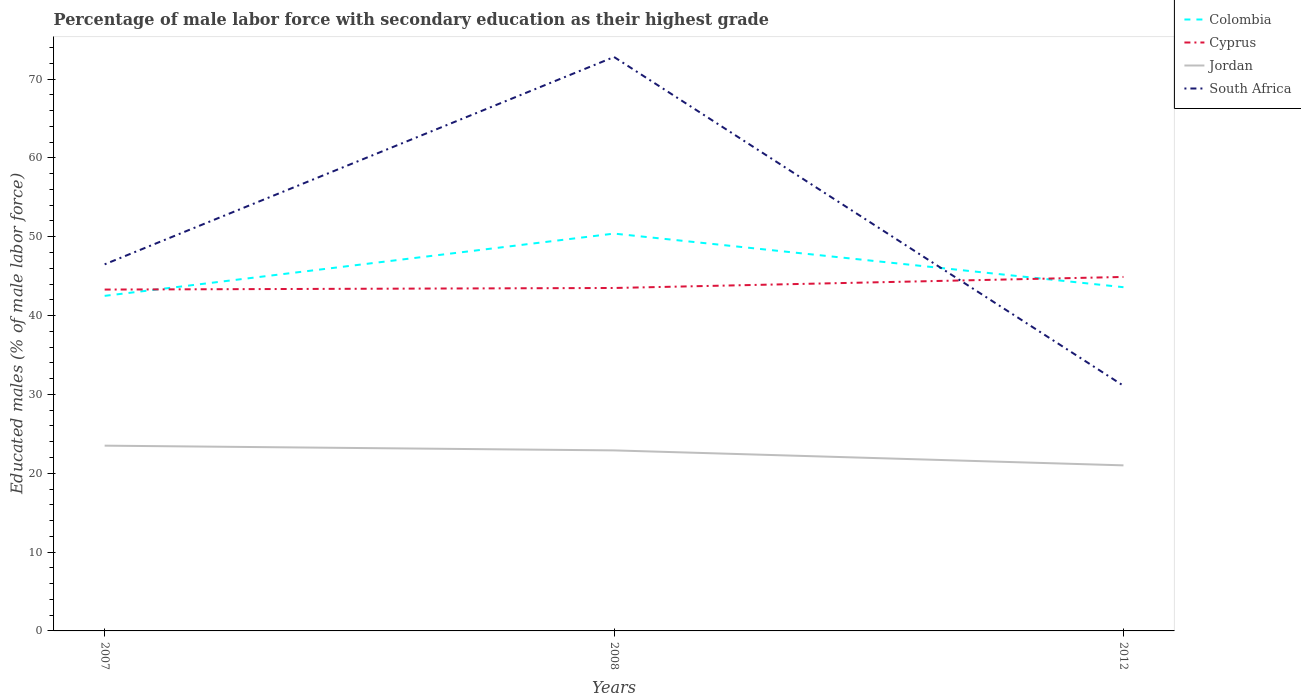Is the number of lines equal to the number of legend labels?
Ensure brevity in your answer.  Yes. Across all years, what is the maximum percentage of male labor force with secondary education in Colombia?
Keep it short and to the point. 42.5. What is the total percentage of male labor force with secondary education in Colombia in the graph?
Provide a short and direct response. -7.9. What is the difference between the highest and the second highest percentage of male labor force with secondary education in Cyprus?
Provide a succinct answer. 1.6. What is the difference between the highest and the lowest percentage of male labor force with secondary education in Cyprus?
Provide a succinct answer. 1. Is the percentage of male labor force with secondary education in Cyprus strictly greater than the percentage of male labor force with secondary education in Colombia over the years?
Provide a succinct answer. No. How many lines are there?
Provide a succinct answer. 4. How many years are there in the graph?
Provide a short and direct response. 3. What is the difference between two consecutive major ticks on the Y-axis?
Provide a short and direct response. 10. Are the values on the major ticks of Y-axis written in scientific E-notation?
Provide a short and direct response. No. Does the graph contain any zero values?
Your response must be concise. No. Does the graph contain grids?
Offer a very short reply. No. Where does the legend appear in the graph?
Offer a very short reply. Top right. How are the legend labels stacked?
Provide a short and direct response. Vertical. What is the title of the graph?
Offer a very short reply. Percentage of male labor force with secondary education as their highest grade. What is the label or title of the X-axis?
Give a very brief answer. Years. What is the label or title of the Y-axis?
Offer a terse response. Educated males (% of male labor force). What is the Educated males (% of male labor force) of Colombia in 2007?
Provide a short and direct response. 42.5. What is the Educated males (% of male labor force) of Cyprus in 2007?
Offer a very short reply. 43.3. What is the Educated males (% of male labor force) of South Africa in 2007?
Make the answer very short. 46.5. What is the Educated males (% of male labor force) in Colombia in 2008?
Make the answer very short. 50.4. What is the Educated males (% of male labor force) of Cyprus in 2008?
Keep it short and to the point. 43.5. What is the Educated males (% of male labor force) in Jordan in 2008?
Give a very brief answer. 22.9. What is the Educated males (% of male labor force) of South Africa in 2008?
Ensure brevity in your answer.  72.8. What is the Educated males (% of male labor force) in Colombia in 2012?
Your answer should be compact. 43.6. What is the Educated males (% of male labor force) of Cyprus in 2012?
Make the answer very short. 44.9. What is the Educated males (% of male labor force) in South Africa in 2012?
Make the answer very short. 31.1. Across all years, what is the maximum Educated males (% of male labor force) of Colombia?
Offer a terse response. 50.4. Across all years, what is the maximum Educated males (% of male labor force) in Cyprus?
Keep it short and to the point. 44.9. Across all years, what is the maximum Educated males (% of male labor force) of Jordan?
Your response must be concise. 23.5. Across all years, what is the maximum Educated males (% of male labor force) in South Africa?
Offer a terse response. 72.8. Across all years, what is the minimum Educated males (% of male labor force) in Colombia?
Make the answer very short. 42.5. Across all years, what is the minimum Educated males (% of male labor force) in Cyprus?
Give a very brief answer. 43.3. Across all years, what is the minimum Educated males (% of male labor force) of Jordan?
Your response must be concise. 21. Across all years, what is the minimum Educated males (% of male labor force) in South Africa?
Your answer should be compact. 31.1. What is the total Educated males (% of male labor force) in Colombia in the graph?
Make the answer very short. 136.5. What is the total Educated males (% of male labor force) in Cyprus in the graph?
Your answer should be very brief. 131.7. What is the total Educated males (% of male labor force) in Jordan in the graph?
Keep it short and to the point. 67.4. What is the total Educated males (% of male labor force) of South Africa in the graph?
Your response must be concise. 150.4. What is the difference between the Educated males (% of male labor force) of Cyprus in 2007 and that in 2008?
Your answer should be very brief. -0.2. What is the difference between the Educated males (% of male labor force) of South Africa in 2007 and that in 2008?
Give a very brief answer. -26.3. What is the difference between the Educated males (% of male labor force) of Cyprus in 2007 and that in 2012?
Keep it short and to the point. -1.6. What is the difference between the Educated males (% of male labor force) of Jordan in 2007 and that in 2012?
Offer a terse response. 2.5. What is the difference between the Educated males (% of male labor force) in South Africa in 2007 and that in 2012?
Ensure brevity in your answer.  15.4. What is the difference between the Educated males (% of male labor force) of Colombia in 2008 and that in 2012?
Your answer should be very brief. 6.8. What is the difference between the Educated males (% of male labor force) of Cyprus in 2008 and that in 2012?
Offer a terse response. -1.4. What is the difference between the Educated males (% of male labor force) of South Africa in 2008 and that in 2012?
Make the answer very short. 41.7. What is the difference between the Educated males (% of male labor force) of Colombia in 2007 and the Educated males (% of male labor force) of Jordan in 2008?
Make the answer very short. 19.6. What is the difference between the Educated males (% of male labor force) in Colombia in 2007 and the Educated males (% of male labor force) in South Africa in 2008?
Give a very brief answer. -30.3. What is the difference between the Educated males (% of male labor force) of Cyprus in 2007 and the Educated males (% of male labor force) of Jordan in 2008?
Keep it short and to the point. 20.4. What is the difference between the Educated males (% of male labor force) in Cyprus in 2007 and the Educated males (% of male labor force) in South Africa in 2008?
Provide a succinct answer. -29.5. What is the difference between the Educated males (% of male labor force) of Jordan in 2007 and the Educated males (% of male labor force) of South Africa in 2008?
Give a very brief answer. -49.3. What is the difference between the Educated males (% of male labor force) of Colombia in 2007 and the Educated males (% of male labor force) of Cyprus in 2012?
Make the answer very short. -2.4. What is the difference between the Educated males (% of male labor force) of Colombia in 2007 and the Educated males (% of male labor force) of Jordan in 2012?
Provide a short and direct response. 21.5. What is the difference between the Educated males (% of male labor force) of Colombia in 2007 and the Educated males (% of male labor force) of South Africa in 2012?
Your answer should be very brief. 11.4. What is the difference between the Educated males (% of male labor force) of Cyprus in 2007 and the Educated males (% of male labor force) of Jordan in 2012?
Provide a short and direct response. 22.3. What is the difference between the Educated males (% of male labor force) of Jordan in 2007 and the Educated males (% of male labor force) of South Africa in 2012?
Offer a terse response. -7.6. What is the difference between the Educated males (% of male labor force) of Colombia in 2008 and the Educated males (% of male labor force) of Jordan in 2012?
Offer a terse response. 29.4. What is the difference between the Educated males (% of male labor force) of Colombia in 2008 and the Educated males (% of male labor force) of South Africa in 2012?
Keep it short and to the point. 19.3. What is the difference between the Educated males (% of male labor force) in Cyprus in 2008 and the Educated males (% of male labor force) in Jordan in 2012?
Offer a terse response. 22.5. What is the difference between the Educated males (% of male labor force) of Jordan in 2008 and the Educated males (% of male labor force) of South Africa in 2012?
Ensure brevity in your answer.  -8.2. What is the average Educated males (% of male labor force) of Colombia per year?
Give a very brief answer. 45.5. What is the average Educated males (% of male labor force) in Cyprus per year?
Your response must be concise. 43.9. What is the average Educated males (% of male labor force) in Jordan per year?
Your answer should be compact. 22.47. What is the average Educated males (% of male labor force) in South Africa per year?
Provide a succinct answer. 50.13. In the year 2007, what is the difference between the Educated males (% of male labor force) of Colombia and Educated males (% of male labor force) of Cyprus?
Provide a succinct answer. -0.8. In the year 2007, what is the difference between the Educated males (% of male labor force) of Cyprus and Educated males (% of male labor force) of Jordan?
Your response must be concise. 19.8. In the year 2007, what is the difference between the Educated males (% of male labor force) in Jordan and Educated males (% of male labor force) in South Africa?
Your answer should be compact. -23. In the year 2008, what is the difference between the Educated males (% of male labor force) in Colombia and Educated males (% of male labor force) in Jordan?
Provide a succinct answer. 27.5. In the year 2008, what is the difference between the Educated males (% of male labor force) in Colombia and Educated males (% of male labor force) in South Africa?
Your answer should be very brief. -22.4. In the year 2008, what is the difference between the Educated males (% of male labor force) in Cyprus and Educated males (% of male labor force) in Jordan?
Offer a very short reply. 20.6. In the year 2008, what is the difference between the Educated males (% of male labor force) of Cyprus and Educated males (% of male labor force) of South Africa?
Your response must be concise. -29.3. In the year 2008, what is the difference between the Educated males (% of male labor force) of Jordan and Educated males (% of male labor force) of South Africa?
Keep it short and to the point. -49.9. In the year 2012, what is the difference between the Educated males (% of male labor force) in Colombia and Educated males (% of male labor force) in Jordan?
Ensure brevity in your answer.  22.6. In the year 2012, what is the difference between the Educated males (% of male labor force) of Cyprus and Educated males (% of male labor force) of Jordan?
Provide a succinct answer. 23.9. What is the ratio of the Educated males (% of male labor force) in Colombia in 2007 to that in 2008?
Offer a very short reply. 0.84. What is the ratio of the Educated males (% of male labor force) in Jordan in 2007 to that in 2008?
Your response must be concise. 1.03. What is the ratio of the Educated males (% of male labor force) in South Africa in 2007 to that in 2008?
Provide a short and direct response. 0.64. What is the ratio of the Educated males (% of male labor force) in Colombia in 2007 to that in 2012?
Your answer should be very brief. 0.97. What is the ratio of the Educated males (% of male labor force) in Cyprus in 2007 to that in 2012?
Your answer should be very brief. 0.96. What is the ratio of the Educated males (% of male labor force) in Jordan in 2007 to that in 2012?
Your response must be concise. 1.12. What is the ratio of the Educated males (% of male labor force) in South Africa in 2007 to that in 2012?
Make the answer very short. 1.5. What is the ratio of the Educated males (% of male labor force) of Colombia in 2008 to that in 2012?
Provide a succinct answer. 1.16. What is the ratio of the Educated males (% of male labor force) in Cyprus in 2008 to that in 2012?
Offer a very short reply. 0.97. What is the ratio of the Educated males (% of male labor force) in Jordan in 2008 to that in 2012?
Your answer should be very brief. 1.09. What is the ratio of the Educated males (% of male labor force) of South Africa in 2008 to that in 2012?
Offer a terse response. 2.34. What is the difference between the highest and the second highest Educated males (% of male labor force) in Jordan?
Keep it short and to the point. 0.6. What is the difference between the highest and the second highest Educated males (% of male labor force) in South Africa?
Your answer should be compact. 26.3. What is the difference between the highest and the lowest Educated males (% of male labor force) in Colombia?
Keep it short and to the point. 7.9. What is the difference between the highest and the lowest Educated males (% of male labor force) in Cyprus?
Your answer should be compact. 1.6. What is the difference between the highest and the lowest Educated males (% of male labor force) of South Africa?
Give a very brief answer. 41.7. 